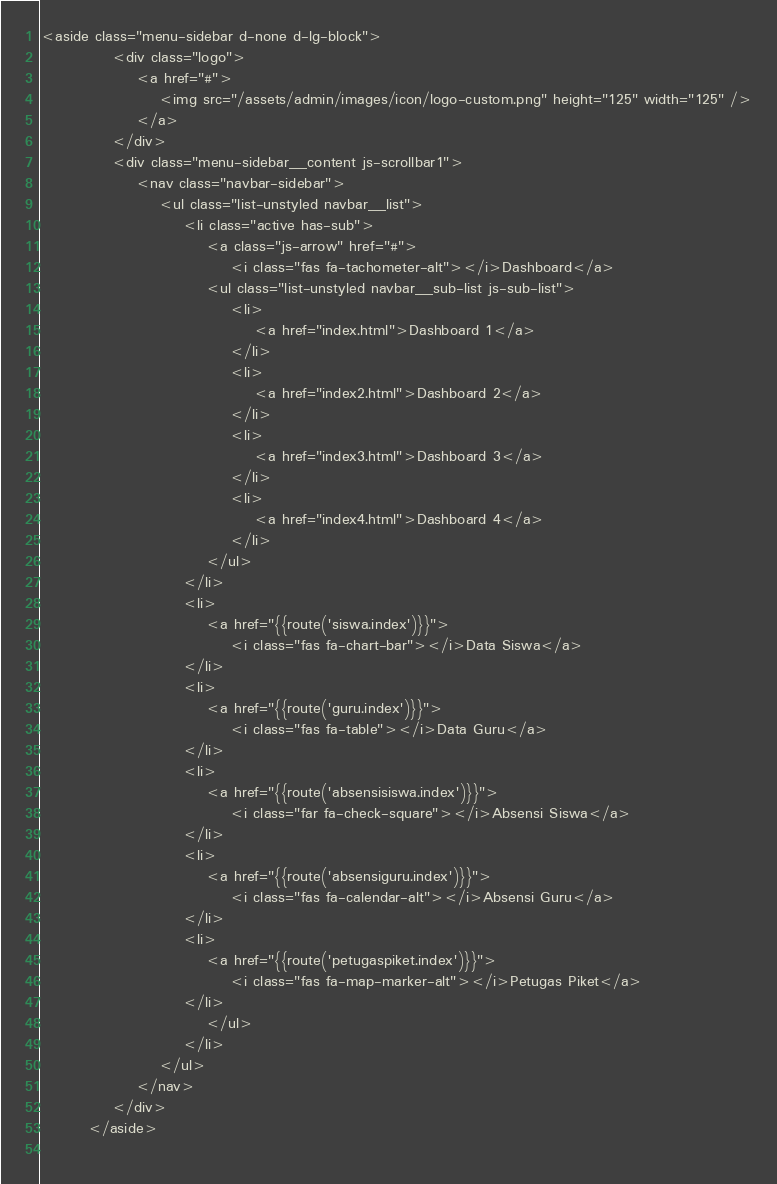<code> <loc_0><loc_0><loc_500><loc_500><_PHP_><aside class="menu-sidebar d-none d-lg-block">
            <div class="logo">
                <a href="#">
                    <img src="/assets/admin/images/icon/logo-custom.png" height="125" width="125" />
                </a>
            </div>
            <div class="menu-sidebar__content js-scrollbar1">
                <nav class="navbar-sidebar">
                    <ul class="list-unstyled navbar__list">
                        <li class="active has-sub">
                            <a class="js-arrow" href="#">
                                <i class="fas fa-tachometer-alt"></i>Dashboard</a>
                            <ul class="list-unstyled navbar__sub-list js-sub-list">
                                <li>
                                    <a href="index.html">Dashboard 1</a>
                                </li>
                                <li>
                                    <a href="index2.html">Dashboard 2</a>
                                </li>
                                <li>
                                    <a href="index3.html">Dashboard 3</a>
                                </li>
                                <li>
                                    <a href="index4.html">Dashboard 4</a>
                                </li>
                            </ul>
                        </li>
                        <li>
                            <a href="{{route('siswa.index')}}">
                                <i class="fas fa-chart-bar"></i>Data Siswa</a>
                        </li>
                        <li>
                            <a href="{{route('guru.index')}}">
                                <i class="fas fa-table"></i>Data Guru</a>
                        </li>
                        <li>
                            <a href="{{route('absensisiswa.index')}}">
                                <i class="far fa-check-square"></i>Absensi Siswa</a>
                        </li>
                        <li>
                            <a href="{{route('absensiguru.index')}}">
                                <i class="fas fa-calendar-alt"></i>Absensi Guru</a>
                        </li>
                        <li>
                            <a href="{{route('petugaspiket.index')}}">
                                <i class="fas fa-map-marker-alt"></i>Petugas Piket</a>
                        </li>
                            </ul>
                        </li>
                    </ul>
                </nav>
            </div>
        </aside>
        </code> 